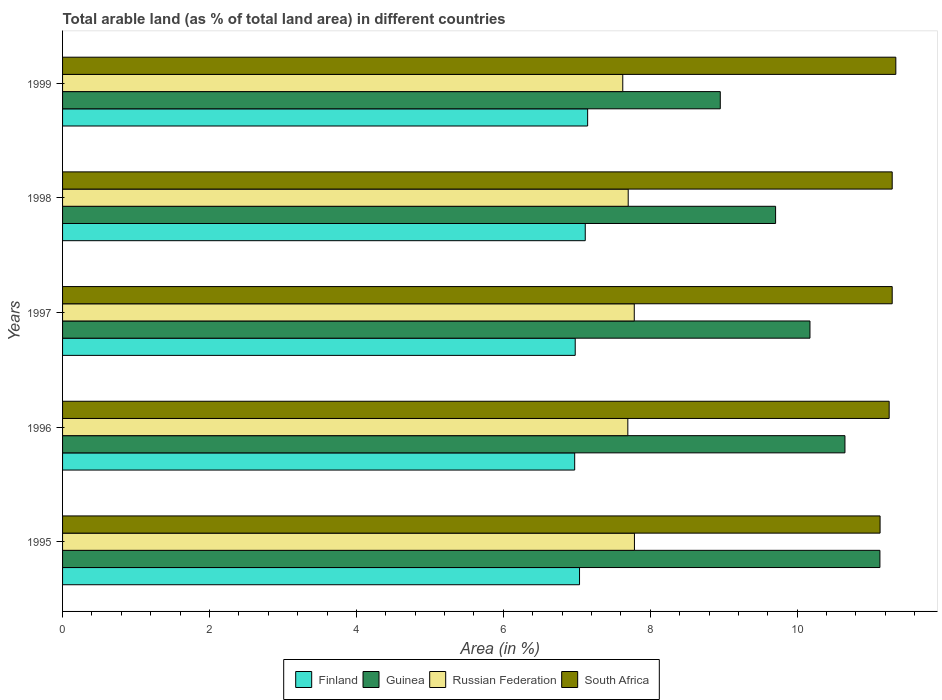How many different coloured bars are there?
Your answer should be very brief. 4. How many groups of bars are there?
Offer a very short reply. 5. Are the number of bars per tick equal to the number of legend labels?
Your answer should be very brief. Yes. What is the label of the 4th group of bars from the top?
Provide a short and direct response. 1996. In how many cases, is the number of bars for a given year not equal to the number of legend labels?
Provide a succinct answer. 0. What is the percentage of arable land in Finland in 1997?
Make the answer very short. 6.98. Across all years, what is the maximum percentage of arable land in Guinea?
Your answer should be very brief. 11.13. Across all years, what is the minimum percentage of arable land in Finland?
Provide a short and direct response. 6.97. What is the total percentage of arable land in South Africa in the graph?
Give a very brief answer. 56.31. What is the difference between the percentage of arable land in Finland in 1996 and that in 1997?
Your answer should be compact. -0.01. What is the difference between the percentage of arable land in Guinea in 1995 and the percentage of arable land in Finland in 1998?
Make the answer very short. 4.01. What is the average percentage of arable land in South Africa per year?
Make the answer very short. 11.26. In the year 1996, what is the difference between the percentage of arable land in Russian Federation and percentage of arable land in South Africa?
Make the answer very short. -3.56. In how many years, is the percentage of arable land in Guinea greater than 5.2 %?
Offer a terse response. 5. What is the ratio of the percentage of arable land in Russian Federation in 1995 to that in 1999?
Ensure brevity in your answer.  1.02. Is the percentage of arable land in South Africa in 1995 less than that in 1997?
Your answer should be very brief. Yes. Is the difference between the percentage of arable land in Russian Federation in 1995 and 1996 greater than the difference between the percentage of arable land in South Africa in 1995 and 1996?
Your answer should be very brief. Yes. What is the difference between the highest and the second highest percentage of arable land in Guinea?
Ensure brevity in your answer.  0.48. What is the difference between the highest and the lowest percentage of arable land in Finland?
Provide a short and direct response. 0.18. Is the sum of the percentage of arable land in South Africa in 1995 and 1997 greater than the maximum percentage of arable land in Russian Federation across all years?
Ensure brevity in your answer.  Yes. What does the 2nd bar from the top in 1998 represents?
Your answer should be compact. Russian Federation. What does the 2nd bar from the bottom in 1998 represents?
Ensure brevity in your answer.  Guinea. Is it the case that in every year, the sum of the percentage of arable land in Finland and percentage of arable land in Russian Federation is greater than the percentage of arable land in South Africa?
Offer a terse response. Yes. How many bars are there?
Provide a succinct answer. 20. How many years are there in the graph?
Your answer should be compact. 5. What is the difference between two consecutive major ticks on the X-axis?
Offer a terse response. 2. Are the values on the major ticks of X-axis written in scientific E-notation?
Provide a succinct answer. No. Does the graph contain any zero values?
Keep it short and to the point. No. Does the graph contain grids?
Keep it short and to the point. No. Where does the legend appear in the graph?
Your answer should be compact. Bottom center. How are the legend labels stacked?
Your answer should be compact. Horizontal. What is the title of the graph?
Make the answer very short. Total arable land (as % of total land area) in different countries. Does "Moldova" appear as one of the legend labels in the graph?
Offer a terse response. No. What is the label or title of the X-axis?
Provide a succinct answer. Area (in %). What is the Area (in %) of Finland in 1995?
Offer a very short reply. 7.04. What is the Area (in %) in Guinea in 1995?
Offer a terse response. 11.13. What is the Area (in %) of Russian Federation in 1995?
Your answer should be very brief. 7.78. What is the Area (in %) of South Africa in 1995?
Give a very brief answer. 11.13. What is the Area (in %) of Finland in 1996?
Your response must be concise. 6.97. What is the Area (in %) of Guinea in 1996?
Offer a very short reply. 10.65. What is the Area (in %) of Russian Federation in 1996?
Offer a very short reply. 7.69. What is the Area (in %) in South Africa in 1996?
Provide a succinct answer. 11.25. What is the Area (in %) of Finland in 1997?
Make the answer very short. 6.98. What is the Area (in %) of Guinea in 1997?
Offer a terse response. 10.17. What is the Area (in %) of Russian Federation in 1997?
Your answer should be compact. 7.78. What is the Area (in %) of South Africa in 1997?
Keep it short and to the point. 11.29. What is the Area (in %) of Finland in 1998?
Your answer should be compact. 7.12. What is the Area (in %) in Guinea in 1998?
Give a very brief answer. 9.71. What is the Area (in %) in Russian Federation in 1998?
Your answer should be compact. 7.7. What is the Area (in %) in South Africa in 1998?
Provide a short and direct response. 11.29. What is the Area (in %) in Finland in 1999?
Ensure brevity in your answer.  7.15. What is the Area (in %) of Guinea in 1999?
Keep it short and to the point. 8.95. What is the Area (in %) of Russian Federation in 1999?
Give a very brief answer. 7.63. What is the Area (in %) in South Africa in 1999?
Your answer should be very brief. 11.34. Across all years, what is the maximum Area (in %) of Finland?
Give a very brief answer. 7.15. Across all years, what is the maximum Area (in %) of Guinea?
Keep it short and to the point. 11.13. Across all years, what is the maximum Area (in %) in Russian Federation?
Your answer should be compact. 7.78. Across all years, what is the maximum Area (in %) in South Africa?
Provide a short and direct response. 11.34. Across all years, what is the minimum Area (in %) in Finland?
Provide a short and direct response. 6.97. Across all years, what is the minimum Area (in %) of Guinea?
Provide a short and direct response. 8.95. Across all years, what is the minimum Area (in %) in Russian Federation?
Your answer should be compact. 7.63. Across all years, what is the minimum Area (in %) of South Africa?
Your answer should be very brief. 11.13. What is the total Area (in %) of Finland in the graph?
Keep it short and to the point. 35.25. What is the total Area (in %) in Guinea in the graph?
Ensure brevity in your answer.  50.61. What is the total Area (in %) of Russian Federation in the graph?
Keep it short and to the point. 38.59. What is the total Area (in %) of South Africa in the graph?
Offer a very short reply. 56.31. What is the difference between the Area (in %) of Finland in 1995 and that in 1996?
Offer a terse response. 0.07. What is the difference between the Area (in %) of Guinea in 1995 and that in 1996?
Offer a terse response. 0.48. What is the difference between the Area (in %) of Russian Federation in 1995 and that in 1996?
Your answer should be compact. 0.09. What is the difference between the Area (in %) of South Africa in 1995 and that in 1996?
Your answer should be very brief. -0.12. What is the difference between the Area (in %) of Finland in 1995 and that in 1997?
Provide a succinct answer. 0.06. What is the difference between the Area (in %) of Guinea in 1995 and that in 1997?
Give a very brief answer. 0.95. What is the difference between the Area (in %) of Russian Federation in 1995 and that in 1997?
Your answer should be compact. 0. What is the difference between the Area (in %) in South Africa in 1995 and that in 1997?
Keep it short and to the point. -0.16. What is the difference between the Area (in %) of Finland in 1995 and that in 1998?
Ensure brevity in your answer.  -0.08. What is the difference between the Area (in %) of Guinea in 1995 and that in 1998?
Provide a succinct answer. 1.42. What is the difference between the Area (in %) of Russian Federation in 1995 and that in 1998?
Make the answer very short. 0.08. What is the difference between the Area (in %) of South Africa in 1995 and that in 1998?
Ensure brevity in your answer.  -0.16. What is the difference between the Area (in %) in Finland in 1995 and that in 1999?
Ensure brevity in your answer.  -0.11. What is the difference between the Area (in %) in Guinea in 1995 and that in 1999?
Provide a succinct answer. 2.17. What is the difference between the Area (in %) in Russian Federation in 1995 and that in 1999?
Offer a terse response. 0.16. What is the difference between the Area (in %) in South Africa in 1995 and that in 1999?
Give a very brief answer. -0.21. What is the difference between the Area (in %) of Finland in 1996 and that in 1997?
Provide a succinct answer. -0.01. What is the difference between the Area (in %) of Guinea in 1996 and that in 1997?
Your answer should be very brief. 0.48. What is the difference between the Area (in %) in Russian Federation in 1996 and that in 1997?
Provide a short and direct response. -0.09. What is the difference between the Area (in %) in South Africa in 1996 and that in 1997?
Your response must be concise. -0.04. What is the difference between the Area (in %) of Finland in 1996 and that in 1998?
Your response must be concise. -0.14. What is the difference between the Area (in %) in Guinea in 1996 and that in 1998?
Give a very brief answer. 0.94. What is the difference between the Area (in %) of Russian Federation in 1996 and that in 1998?
Make the answer very short. -0.01. What is the difference between the Area (in %) of South Africa in 1996 and that in 1998?
Provide a short and direct response. -0.04. What is the difference between the Area (in %) in Finland in 1996 and that in 1999?
Offer a terse response. -0.18. What is the difference between the Area (in %) in Guinea in 1996 and that in 1999?
Give a very brief answer. 1.7. What is the difference between the Area (in %) of Russian Federation in 1996 and that in 1999?
Your response must be concise. 0.07. What is the difference between the Area (in %) of South Africa in 1996 and that in 1999?
Your answer should be very brief. -0.09. What is the difference between the Area (in %) of Finland in 1997 and that in 1998?
Ensure brevity in your answer.  -0.14. What is the difference between the Area (in %) of Guinea in 1997 and that in 1998?
Your answer should be compact. 0.47. What is the difference between the Area (in %) in Russian Federation in 1997 and that in 1998?
Offer a very short reply. 0.08. What is the difference between the Area (in %) in South Africa in 1997 and that in 1998?
Your answer should be very brief. 0. What is the difference between the Area (in %) of Finland in 1997 and that in 1999?
Your answer should be very brief. -0.17. What is the difference between the Area (in %) in Guinea in 1997 and that in 1999?
Make the answer very short. 1.22. What is the difference between the Area (in %) of Russian Federation in 1997 and that in 1999?
Make the answer very short. 0.16. What is the difference between the Area (in %) in South Africa in 1997 and that in 1999?
Your response must be concise. -0.05. What is the difference between the Area (in %) of Finland in 1998 and that in 1999?
Your answer should be compact. -0.03. What is the difference between the Area (in %) of Guinea in 1998 and that in 1999?
Keep it short and to the point. 0.75. What is the difference between the Area (in %) in Russian Federation in 1998 and that in 1999?
Offer a very short reply. 0.07. What is the difference between the Area (in %) in South Africa in 1998 and that in 1999?
Provide a succinct answer. -0.05. What is the difference between the Area (in %) in Finland in 1995 and the Area (in %) in Guinea in 1996?
Keep it short and to the point. -3.61. What is the difference between the Area (in %) in Finland in 1995 and the Area (in %) in Russian Federation in 1996?
Give a very brief answer. -0.66. What is the difference between the Area (in %) of Finland in 1995 and the Area (in %) of South Africa in 1996?
Your answer should be very brief. -4.21. What is the difference between the Area (in %) of Guinea in 1995 and the Area (in %) of Russian Federation in 1996?
Your answer should be very brief. 3.43. What is the difference between the Area (in %) in Guinea in 1995 and the Area (in %) in South Africa in 1996?
Your response must be concise. -0.13. What is the difference between the Area (in %) in Russian Federation in 1995 and the Area (in %) in South Africa in 1996?
Your answer should be compact. -3.47. What is the difference between the Area (in %) of Finland in 1995 and the Area (in %) of Guinea in 1997?
Provide a short and direct response. -3.14. What is the difference between the Area (in %) of Finland in 1995 and the Area (in %) of Russian Federation in 1997?
Offer a terse response. -0.75. What is the difference between the Area (in %) of Finland in 1995 and the Area (in %) of South Africa in 1997?
Provide a succinct answer. -4.26. What is the difference between the Area (in %) in Guinea in 1995 and the Area (in %) in Russian Federation in 1997?
Give a very brief answer. 3.34. What is the difference between the Area (in %) in Guinea in 1995 and the Area (in %) in South Africa in 1997?
Your answer should be compact. -0.17. What is the difference between the Area (in %) in Russian Federation in 1995 and the Area (in %) in South Africa in 1997?
Provide a short and direct response. -3.51. What is the difference between the Area (in %) of Finland in 1995 and the Area (in %) of Guinea in 1998?
Make the answer very short. -2.67. What is the difference between the Area (in %) of Finland in 1995 and the Area (in %) of Russian Federation in 1998?
Provide a short and direct response. -0.66. What is the difference between the Area (in %) in Finland in 1995 and the Area (in %) in South Africa in 1998?
Ensure brevity in your answer.  -4.26. What is the difference between the Area (in %) in Guinea in 1995 and the Area (in %) in Russian Federation in 1998?
Your response must be concise. 3.43. What is the difference between the Area (in %) of Guinea in 1995 and the Area (in %) of South Africa in 1998?
Provide a succinct answer. -0.17. What is the difference between the Area (in %) of Russian Federation in 1995 and the Area (in %) of South Africa in 1998?
Offer a very short reply. -3.51. What is the difference between the Area (in %) in Finland in 1995 and the Area (in %) in Guinea in 1999?
Provide a short and direct response. -1.92. What is the difference between the Area (in %) in Finland in 1995 and the Area (in %) in Russian Federation in 1999?
Your response must be concise. -0.59. What is the difference between the Area (in %) of Finland in 1995 and the Area (in %) of South Africa in 1999?
Give a very brief answer. -4.31. What is the difference between the Area (in %) of Guinea in 1995 and the Area (in %) of Russian Federation in 1999?
Provide a short and direct response. 3.5. What is the difference between the Area (in %) of Guinea in 1995 and the Area (in %) of South Africa in 1999?
Make the answer very short. -0.22. What is the difference between the Area (in %) of Russian Federation in 1995 and the Area (in %) of South Africa in 1999?
Make the answer very short. -3.56. What is the difference between the Area (in %) of Finland in 1996 and the Area (in %) of Guinea in 1997?
Offer a very short reply. -3.2. What is the difference between the Area (in %) in Finland in 1996 and the Area (in %) in Russian Federation in 1997?
Offer a very short reply. -0.81. What is the difference between the Area (in %) of Finland in 1996 and the Area (in %) of South Africa in 1997?
Your response must be concise. -4.32. What is the difference between the Area (in %) in Guinea in 1996 and the Area (in %) in Russian Federation in 1997?
Provide a succinct answer. 2.87. What is the difference between the Area (in %) of Guinea in 1996 and the Area (in %) of South Africa in 1997?
Offer a terse response. -0.64. What is the difference between the Area (in %) in Russian Federation in 1996 and the Area (in %) in South Africa in 1997?
Ensure brevity in your answer.  -3.6. What is the difference between the Area (in %) of Finland in 1996 and the Area (in %) of Guinea in 1998?
Offer a very short reply. -2.73. What is the difference between the Area (in %) in Finland in 1996 and the Area (in %) in Russian Federation in 1998?
Ensure brevity in your answer.  -0.73. What is the difference between the Area (in %) of Finland in 1996 and the Area (in %) of South Africa in 1998?
Offer a very short reply. -4.32. What is the difference between the Area (in %) in Guinea in 1996 and the Area (in %) in Russian Federation in 1998?
Keep it short and to the point. 2.95. What is the difference between the Area (in %) of Guinea in 1996 and the Area (in %) of South Africa in 1998?
Your response must be concise. -0.64. What is the difference between the Area (in %) in Russian Federation in 1996 and the Area (in %) in South Africa in 1998?
Offer a terse response. -3.6. What is the difference between the Area (in %) in Finland in 1996 and the Area (in %) in Guinea in 1999?
Offer a very short reply. -1.98. What is the difference between the Area (in %) of Finland in 1996 and the Area (in %) of Russian Federation in 1999?
Offer a terse response. -0.65. What is the difference between the Area (in %) of Finland in 1996 and the Area (in %) of South Africa in 1999?
Keep it short and to the point. -4.37. What is the difference between the Area (in %) of Guinea in 1996 and the Area (in %) of Russian Federation in 1999?
Keep it short and to the point. 3.02. What is the difference between the Area (in %) of Guinea in 1996 and the Area (in %) of South Africa in 1999?
Your response must be concise. -0.69. What is the difference between the Area (in %) in Russian Federation in 1996 and the Area (in %) in South Africa in 1999?
Your answer should be compact. -3.65. What is the difference between the Area (in %) in Finland in 1997 and the Area (in %) in Guinea in 1998?
Give a very brief answer. -2.73. What is the difference between the Area (in %) of Finland in 1997 and the Area (in %) of Russian Federation in 1998?
Make the answer very short. -0.72. What is the difference between the Area (in %) of Finland in 1997 and the Area (in %) of South Africa in 1998?
Keep it short and to the point. -4.31. What is the difference between the Area (in %) of Guinea in 1997 and the Area (in %) of Russian Federation in 1998?
Your response must be concise. 2.47. What is the difference between the Area (in %) in Guinea in 1997 and the Area (in %) in South Africa in 1998?
Offer a terse response. -1.12. What is the difference between the Area (in %) in Russian Federation in 1997 and the Area (in %) in South Africa in 1998?
Your answer should be compact. -3.51. What is the difference between the Area (in %) of Finland in 1997 and the Area (in %) of Guinea in 1999?
Your response must be concise. -1.97. What is the difference between the Area (in %) in Finland in 1997 and the Area (in %) in Russian Federation in 1999?
Provide a short and direct response. -0.65. What is the difference between the Area (in %) in Finland in 1997 and the Area (in %) in South Africa in 1999?
Offer a terse response. -4.36. What is the difference between the Area (in %) in Guinea in 1997 and the Area (in %) in Russian Federation in 1999?
Your answer should be very brief. 2.55. What is the difference between the Area (in %) of Guinea in 1997 and the Area (in %) of South Africa in 1999?
Your answer should be very brief. -1.17. What is the difference between the Area (in %) in Russian Federation in 1997 and the Area (in %) in South Africa in 1999?
Keep it short and to the point. -3.56. What is the difference between the Area (in %) of Finland in 1998 and the Area (in %) of Guinea in 1999?
Provide a short and direct response. -1.84. What is the difference between the Area (in %) in Finland in 1998 and the Area (in %) in Russian Federation in 1999?
Make the answer very short. -0.51. What is the difference between the Area (in %) in Finland in 1998 and the Area (in %) in South Africa in 1999?
Ensure brevity in your answer.  -4.23. What is the difference between the Area (in %) in Guinea in 1998 and the Area (in %) in Russian Federation in 1999?
Ensure brevity in your answer.  2.08. What is the difference between the Area (in %) of Guinea in 1998 and the Area (in %) of South Africa in 1999?
Ensure brevity in your answer.  -1.64. What is the difference between the Area (in %) of Russian Federation in 1998 and the Area (in %) of South Africa in 1999?
Give a very brief answer. -3.64. What is the average Area (in %) of Finland per year?
Provide a succinct answer. 7.05. What is the average Area (in %) in Guinea per year?
Make the answer very short. 10.12. What is the average Area (in %) of Russian Federation per year?
Offer a terse response. 7.72. What is the average Area (in %) in South Africa per year?
Your answer should be very brief. 11.26. In the year 1995, what is the difference between the Area (in %) of Finland and Area (in %) of Guinea?
Give a very brief answer. -4.09. In the year 1995, what is the difference between the Area (in %) in Finland and Area (in %) in Russian Federation?
Offer a very short reply. -0.75. In the year 1995, what is the difference between the Area (in %) of Finland and Area (in %) of South Africa?
Provide a succinct answer. -4.09. In the year 1995, what is the difference between the Area (in %) of Guinea and Area (in %) of Russian Federation?
Give a very brief answer. 3.34. In the year 1995, what is the difference between the Area (in %) in Guinea and Area (in %) in South Africa?
Give a very brief answer. -0. In the year 1995, what is the difference between the Area (in %) in Russian Federation and Area (in %) in South Africa?
Make the answer very short. -3.34. In the year 1996, what is the difference between the Area (in %) in Finland and Area (in %) in Guinea?
Provide a short and direct response. -3.68. In the year 1996, what is the difference between the Area (in %) of Finland and Area (in %) of Russian Federation?
Your answer should be compact. -0.72. In the year 1996, what is the difference between the Area (in %) of Finland and Area (in %) of South Africa?
Offer a terse response. -4.28. In the year 1996, what is the difference between the Area (in %) in Guinea and Area (in %) in Russian Federation?
Provide a succinct answer. 2.96. In the year 1996, what is the difference between the Area (in %) in Guinea and Area (in %) in South Africa?
Provide a short and direct response. -0.6. In the year 1996, what is the difference between the Area (in %) in Russian Federation and Area (in %) in South Africa?
Offer a terse response. -3.56. In the year 1997, what is the difference between the Area (in %) in Finland and Area (in %) in Guinea?
Keep it short and to the point. -3.2. In the year 1997, what is the difference between the Area (in %) in Finland and Area (in %) in Russian Federation?
Give a very brief answer. -0.8. In the year 1997, what is the difference between the Area (in %) of Finland and Area (in %) of South Africa?
Ensure brevity in your answer.  -4.31. In the year 1997, what is the difference between the Area (in %) in Guinea and Area (in %) in Russian Federation?
Ensure brevity in your answer.  2.39. In the year 1997, what is the difference between the Area (in %) in Guinea and Area (in %) in South Africa?
Give a very brief answer. -1.12. In the year 1997, what is the difference between the Area (in %) of Russian Federation and Area (in %) of South Africa?
Make the answer very short. -3.51. In the year 1998, what is the difference between the Area (in %) in Finland and Area (in %) in Guinea?
Offer a terse response. -2.59. In the year 1998, what is the difference between the Area (in %) in Finland and Area (in %) in Russian Federation?
Keep it short and to the point. -0.58. In the year 1998, what is the difference between the Area (in %) in Finland and Area (in %) in South Africa?
Your answer should be compact. -4.18. In the year 1998, what is the difference between the Area (in %) of Guinea and Area (in %) of Russian Federation?
Make the answer very short. 2.01. In the year 1998, what is the difference between the Area (in %) in Guinea and Area (in %) in South Africa?
Your response must be concise. -1.59. In the year 1998, what is the difference between the Area (in %) in Russian Federation and Area (in %) in South Africa?
Offer a terse response. -3.59. In the year 1999, what is the difference between the Area (in %) in Finland and Area (in %) in Guinea?
Your response must be concise. -1.81. In the year 1999, what is the difference between the Area (in %) of Finland and Area (in %) of Russian Federation?
Give a very brief answer. -0.48. In the year 1999, what is the difference between the Area (in %) in Finland and Area (in %) in South Africa?
Ensure brevity in your answer.  -4.2. In the year 1999, what is the difference between the Area (in %) in Guinea and Area (in %) in Russian Federation?
Provide a succinct answer. 1.33. In the year 1999, what is the difference between the Area (in %) of Guinea and Area (in %) of South Africa?
Offer a terse response. -2.39. In the year 1999, what is the difference between the Area (in %) in Russian Federation and Area (in %) in South Africa?
Your answer should be very brief. -3.72. What is the ratio of the Area (in %) in Finland in 1995 to that in 1996?
Ensure brevity in your answer.  1.01. What is the ratio of the Area (in %) in Guinea in 1995 to that in 1996?
Give a very brief answer. 1.04. What is the ratio of the Area (in %) in Russian Federation in 1995 to that in 1996?
Your response must be concise. 1.01. What is the ratio of the Area (in %) in South Africa in 1995 to that in 1996?
Provide a succinct answer. 0.99. What is the ratio of the Area (in %) in Finland in 1995 to that in 1997?
Ensure brevity in your answer.  1.01. What is the ratio of the Area (in %) of Guinea in 1995 to that in 1997?
Provide a succinct answer. 1.09. What is the ratio of the Area (in %) of South Africa in 1995 to that in 1997?
Your answer should be very brief. 0.99. What is the ratio of the Area (in %) in Guinea in 1995 to that in 1998?
Offer a terse response. 1.15. What is the ratio of the Area (in %) in South Africa in 1995 to that in 1998?
Offer a very short reply. 0.99. What is the ratio of the Area (in %) in Finland in 1995 to that in 1999?
Provide a short and direct response. 0.98. What is the ratio of the Area (in %) in Guinea in 1995 to that in 1999?
Your answer should be very brief. 1.24. What is the ratio of the Area (in %) in Russian Federation in 1995 to that in 1999?
Offer a very short reply. 1.02. What is the ratio of the Area (in %) of South Africa in 1995 to that in 1999?
Keep it short and to the point. 0.98. What is the ratio of the Area (in %) in Finland in 1996 to that in 1997?
Keep it short and to the point. 1. What is the ratio of the Area (in %) in Guinea in 1996 to that in 1997?
Provide a succinct answer. 1.05. What is the ratio of the Area (in %) of Russian Federation in 1996 to that in 1997?
Keep it short and to the point. 0.99. What is the ratio of the Area (in %) in Finland in 1996 to that in 1998?
Offer a very short reply. 0.98. What is the ratio of the Area (in %) in Guinea in 1996 to that in 1998?
Offer a terse response. 1.1. What is the ratio of the Area (in %) in Russian Federation in 1996 to that in 1998?
Offer a very short reply. 1. What is the ratio of the Area (in %) of Finland in 1996 to that in 1999?
Provide a succinct answer. 0.98. What is the ratio of the Area (in %) of Guinea in 1996 to that in 1999?
Provide a succinct answer. 1.19. What is the ratio of the Area (in %) in South Africa in 1996 to that in 1999?
Your answer should be compact. 0.99. What is the ratio of the Area (in %) in Finland in 1997 to that in 1998?
Provide a succinct answer. 0.98. What is the ratio of the Area (in %) of Guinea in 1997 to that in 1998?
Offer a very short reply. 1.05. What is the ratio of the Area (in %) of Russian Federation in 1997 to that in 1998?
Your response must be concise. 1.01. What is the ratio of the Area (in %) of South Africa in 1997 to that in 1998?
Your answer should be very brief. 1. What is the ratio of the Area (in %) of Finland in 1997 to that in 1999?
Provide a short and direct response. 0.98. What is the ratio of the Area (in %) of Guinea in 1997 to that in 1999?
Provide a succinct answer. 1.14. What is the ratio of the Area (in %) in Russian Federation in 1997 to that in 1999?
Your answer should be compact. 1.02. What is the ratio of the Area (in %) in Finland in 1998 to that in 1999?
Provide a short and direct response. 1. What is the ratio of the Area (in %) of Guinea in 1998 to that in 1999?
Your answer should be compact. 1.08. What is the ratio of the Area (in %) in Russian Federation in 1998 to that in 1999?
Provide a short and direct response. 1.01. What is the difference between the highest and the second highest Area (in %) in Finland?
Make the answer very short. 0.03. What is the difference between the highest and the second highest Area (in %) in Guinea?
Your answer should be compact. 0.48. What is the difference between the highest and the second highest Area (in %) in Russian Federation?
Ensure brevity in your answer.  0. What is the difference between the highest and the second highest Area (in %) of South Africa?
Make the answer very short. 0.05. What is the difference between the highest and the lowest Area (in %) in Finland?
Make the answer very short. 0.18. What is the difference between the highest and the lowest Area (in %) in Guinea?
Offer a terse response. 2.17. What is the difference between the highest and the lowest Area (in %) in Russian Federation?
Make the answer very short. 0.16. What is the difference between the highest and the lowest Area (in %) in South Africa?
Make the answer very short. 0.21. 